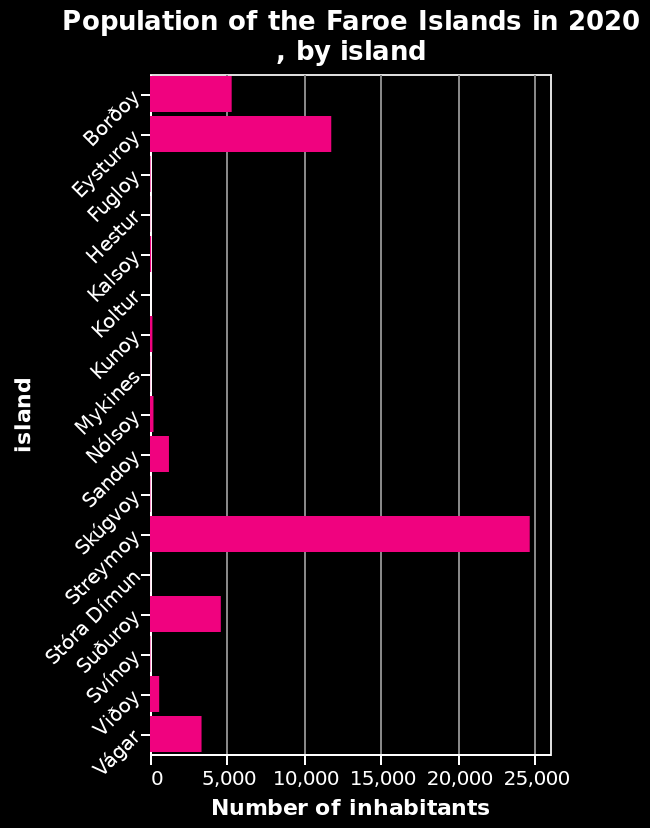<image>
What is the population of Streymoy? Streymoy has a population of 25,000 inhabitants. What does the x-axis represent in the bar diagram? The x-axis in the bar diagram represents the number of inhabitants. What type of diagram is being used to represent the data? A bar diagram is being used to represent the data. 